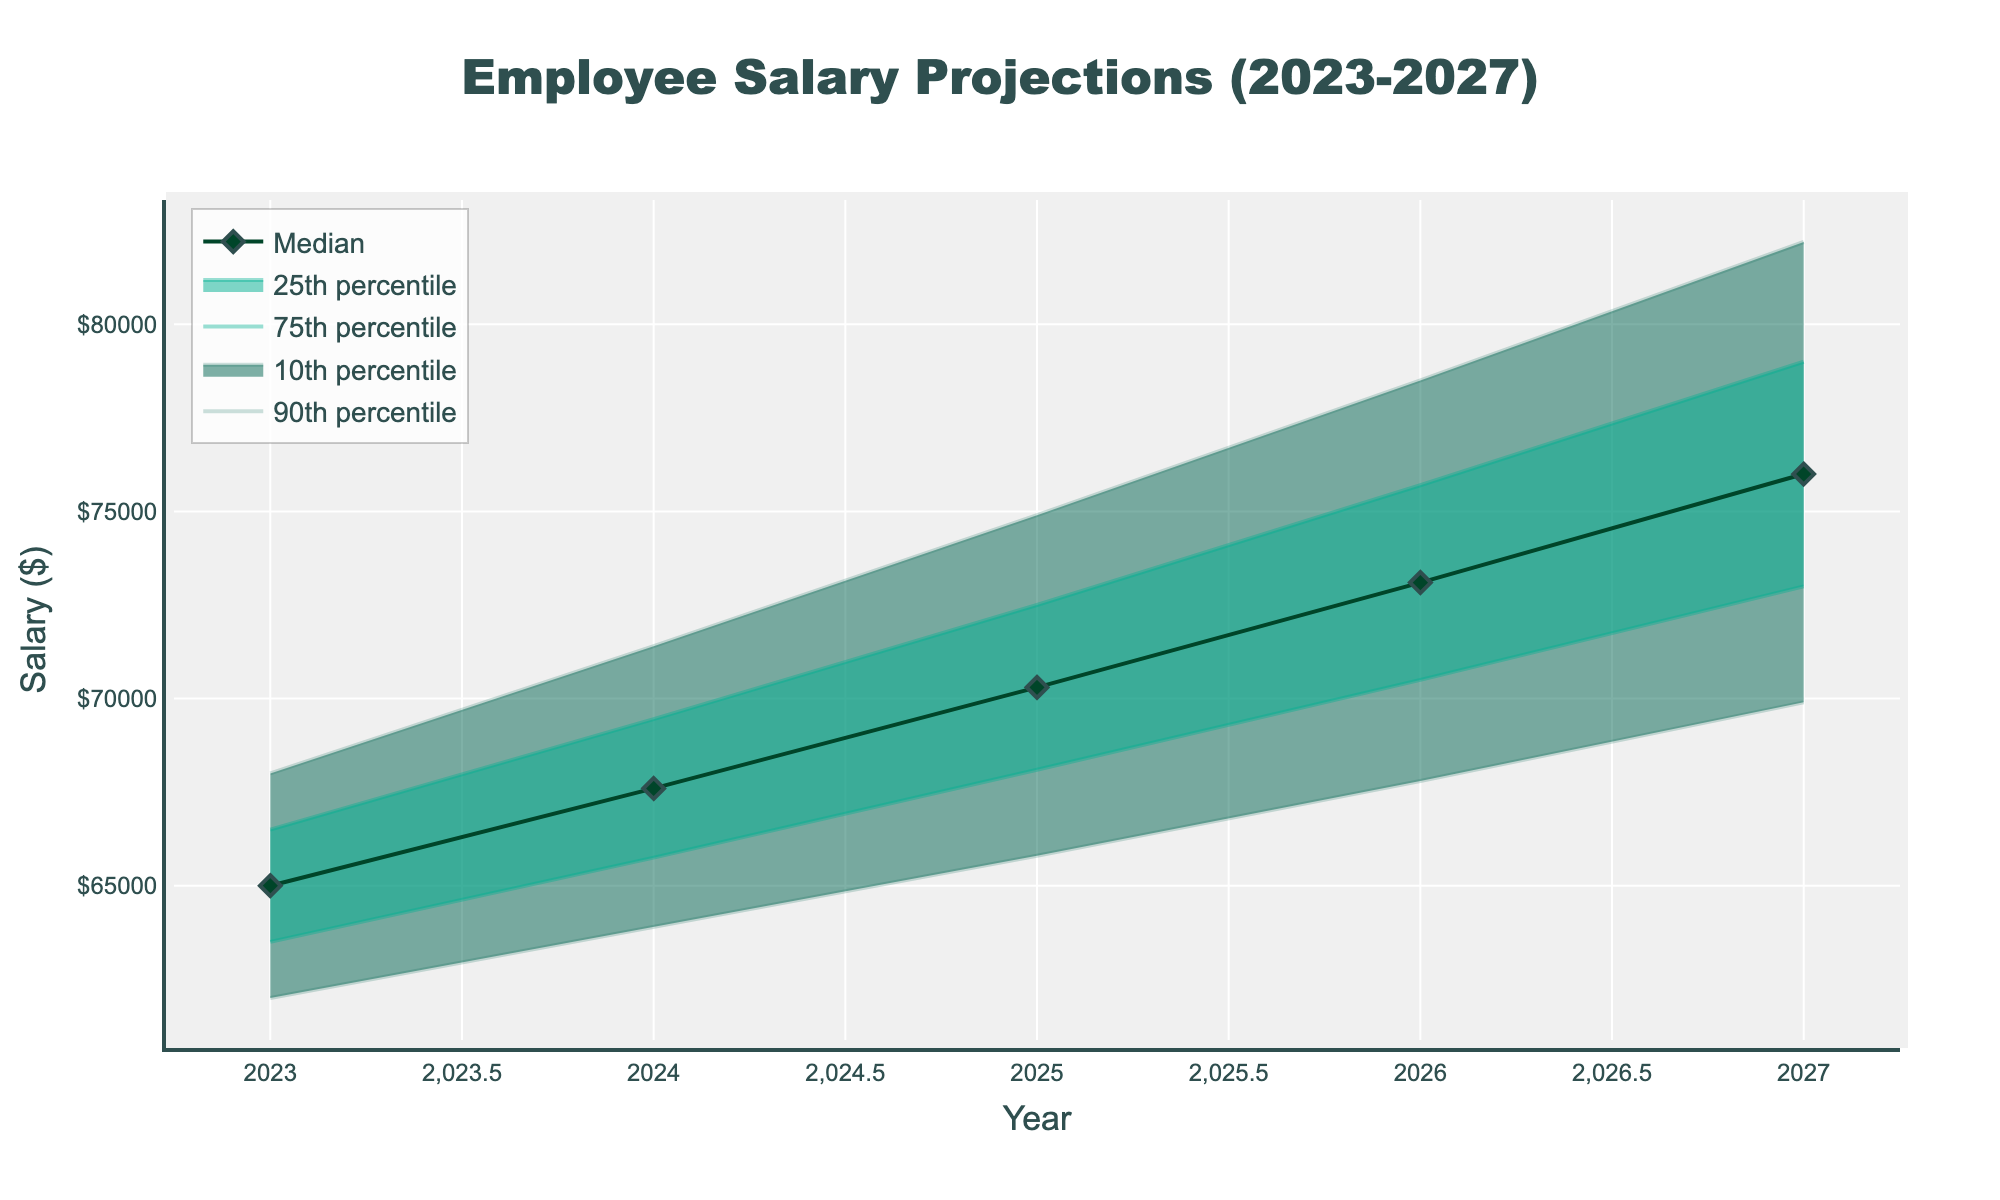What is the title of the plot? The title is usually found at the top of the plot. In this plot, it reads "Employee Salary Projections (2023-2027)"
Answer: Employee Salary Projections (2023-2027) What is the median projected salary for the year 2025? Look for the median line (indicated by markers) and find the corresponding value for the year 2025 on the x-axis.
Answer: $70,300 What are the upper and lower 90th percentile salary projections for 2027? Find the lines corresponding to the upper and lower 90th percentiles, then read the values for the year 2027 on the x-axis.
Answer: Upper: $82,200; Lower: $69,900 By how much is the median salary projected to increase from 2023 to 2027? Subtract the median salary for 2023 from the median salary for 2027. For 2023 it is $65,000, and for 2027 it is $76,000. The increase is $76,000 - $65,000.
Answer: $11,000 How does the 25th percentile salary for 2025 compare to the 75th percentile salary for 2025? Find the values for the 25th and 75th percentiles in 2025 and compare them. The 25th percentile is $68,100, and the 75th percentile is $72,500.
Answer: The 25th percentile is lower What is the range of the salary projections for 2024 within the 10th to 90th percentiles? Find the values of the 10th and 90th percentiles for 2024 and compute the difference. The 10th percentile is $63,900 and the 90th percentile is $71,400, so the range is $71,400 - $63,900.
Answer: $7,500 Are median salaries projected to increase or decrease over the five years? Look at the trend of the median line from 2023 to 2027. All median values increase each year ($65,000, $67,600, $70,300, $73,100, $76,000).
Answer: Increase What is the projected salary range for the year 2026 between the 25th and 75th percentiles? Find the values for the 25th and 75th percentiles in 2026 and compute the difference. The 25th percentile is $70,500 and the 75th percentile is $75,700.
Answer: $5,200 What is the upper 90th percentile salary projection for the final year in the chart? Locate the upper 90th percentile line and find the value for the year 2027.
Answer: $82,200 By how much is the median salary projected to increase each year? Calculate the yearly differences between median salaries. From 2023 to 2024: $67,600 - $65,000 = $2,600, from 2024 to 2025: $70,300 - $67,600 = $2,700, etc.
Answer: $2,600->$2,700->$2,800 